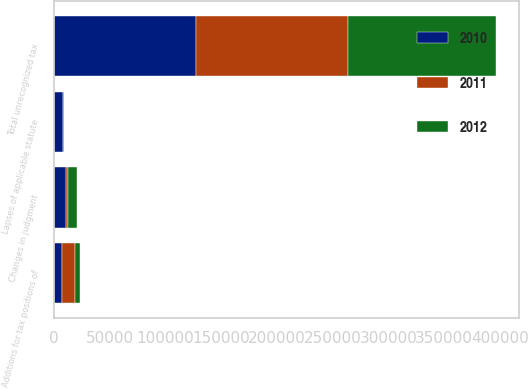Convert chart. <chart><loc_0><loc_0><loc_500><loc_500><stacked_bar_chart><ecel><fcel>Total unrecognized tax<fcel>Additions for tax positions of<fcel>Changes in judgment<fcel>Lapses of applicable statute<nl><fcel>2012<fcel>133422<fcel>5167<fcel>7729<fcel>21<nl><fcel>2011<fcel>136005<fcel>10915<fcel>1555<fcel>826<nl><fcel>2010<fcel>127595<fcel>7551<fcel>11017<fcel>7956<nl></chart> 